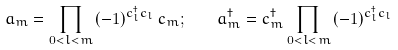<formula> <loc_0><loc_0><loc_500><loc_500>a _ { m } = \prod _ { 0 < l < m } \, ( - 1 ) ^ { c ^ { \dagger } _ { l } c _ { l } } \, c _ { m } ; \quad a ^ { \dagger } _ { m } = c ^ { \dagger } _ { m } \prod _ { 0 < l < m } \, ( - 1 ) ^ { c ^ { \dagger } _ { l } c _ { l } }</formula> 